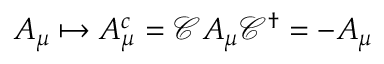Convert formula to latex. <formula><loc_0><loc_0><loc_500><loc_500>A _ { \mu } \mapsto A _ { \mu } ^ { c } = { \mathcal { C } } A _ { \mu } { \mathcal { C } } ^ { \dagger } = - A _ { \mu }</formula> 